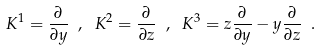<formula> <loc_0><loc_0><loc_500><loc_500>K ^ { 1 } = \frac { \partial } { \partial y } \ , \ K ^ { 2 } = \frac { \partial } { \partial z } \ , \ K ^ { 3 } = z \frac { \partial } { \partial y } - y \frac { \partial } { \partial z } \ .</formula> 